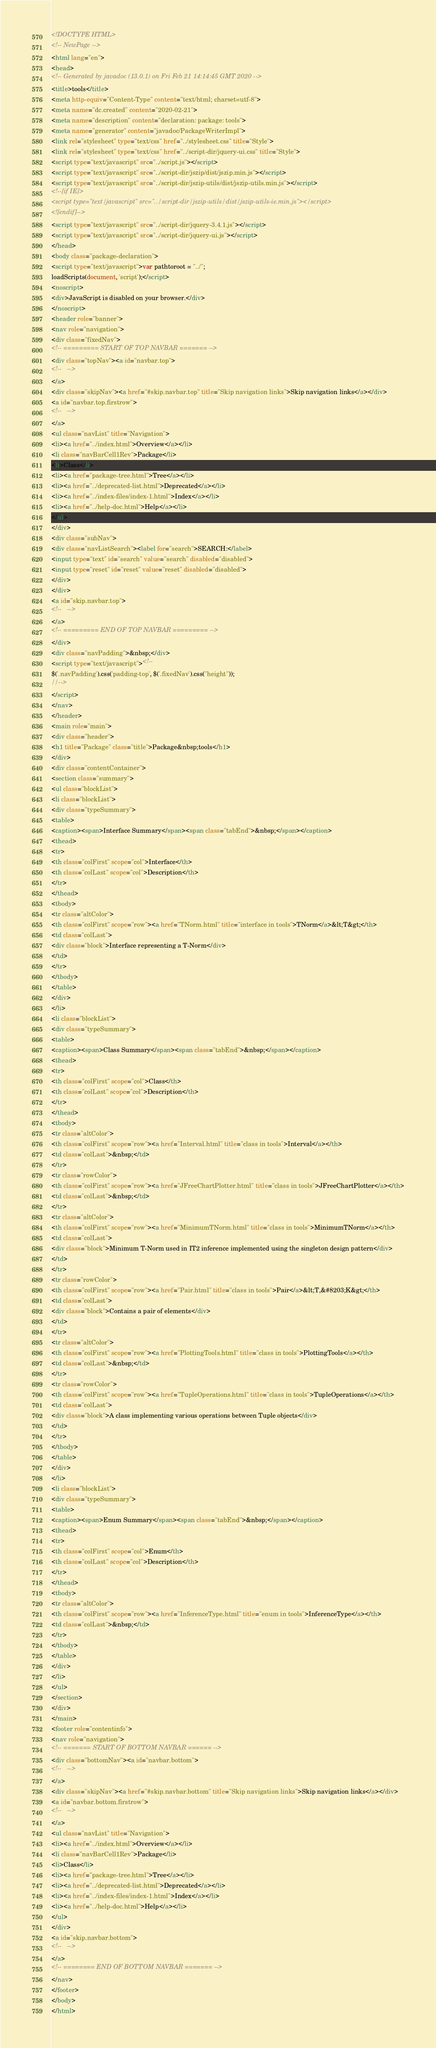<code> <loc_0><loc_0><loc_500><loc_500><_HTML_><!DOCTYPE HTML>
<!-- NewPage -->
<html lang="en">
<head>
<!-- Generated by javadoc (13.0.1) on Fri Feb 21 14:14:45 GMT 2020 -->
<title>tools</title>
<meta http-equiv="Content-Type" content="text/html; charset=utf-8">
<meta name="dc.created" content="2020-02-21">
<meta name="description" content="declaration: package: tools">
<meta name="generator" content="javadoc/PackageWriterImpl">
<link rel="stylesheet" type="text/css" href="../stylesheet.css" title="Style">
<link rel="stylesheet" type="text/css" href="../script-dir/jquery-ui.css" title="Style">
<script type="text/javascript" src="../script.js"></script>
<script type="text/javascript" src="../script-dir/jszip/dist/jszip.min.js"></script>
<script type="text/javascript" src="../script-dir/jszip-utils/dist/jszip-utils.min.js"></script>
<!--[if IE]>
<script type="text/javascript" src="../script-dir/jszip-utils/dist/jszip-utils-ie.min.js"></script>
<![endif]-->
<script type="text/javascript" src="../script-dir/jquery-3.4.1.js"></script>
<script type="text/javascript" src="../script-dir/jquery-ui.js"></script>
</head>
<body class="package-declaration">
<script type="text/javascript">var pathtoroot = "../";
loadScripts(document, 'script');</script>
<noscript>
<div>JavaScript is disabled on your browser.</div>
</noscript>
<header role="banner">
<nav role="navigation">
<div class="fixedNav">
<!-- ========= START OF TOP NAVBAR ======= -->
<div class="topNav"><a id="navbar.top">
<!--   -->
</a>
<div class="skipNav"><a href="#skip.navbar.top" title="Skip navigation links">Skip navigation links</a></div>
<a id="navbar.top.firstrow">
<!--   -->
</a>
<ul class="navList" title="Navigation">
<li><a href="../index.html">Overview</a></li>
<li class="navBarCell1Rev">Package</li>
<li>Class</li>
<li><a href="package-tree.html">Tree</a></li>
<li><a href="../deprecated-list.html">Deprecated</a></li>
<li><a href="../index-files/index-1.html">Index</a></li>
<li><a href="../help-doc.html">Help</a></li>
</ul>
</div>
<div class="subNav">
<div class="navListSearch"><label for="search">SEARCH:</label>
<input type="text" id="search" value="search" disabled="disabled">
<input type="reset" id="reset" value="reset" disabled="disabled">
</div>
</div>
<a id="skip.navbar.top">
<!--   -->
</a>
<!-- ========= END OF TOP NAVBAR ========= -->
</div>
<div class="navPadding">&nbsp;</div>
<script type="text/javascript"><!--
$('.navPadding').css('padding-top', $('.fixedNav').css("height"));
//-->
</script>
</nav>
</header>
<main role="main">
<div class="header">
<h1 title="Package" class="title">Package&nbsp;tools</h1>
</div>
<div class="contentContainer">
<section class="summary">
<ul class="blockList">
<li class="blockList">
<div class="typeSummary">
<table>
<caption><span>Interface Summary</span><span class="tabEnd">&nbsp;</span></caption>
<thead>
<tr>
<th class="colFirst" scope="col">Interface</th>
<th class="colLast" scope="col">Description</th>
</tr>
</thead>
<tbody>
<tr class="altColor">
<th class="colFirst" scope="row"><a href="TNorm.html" title="interface in tools">TNorm</a>&lt;T&gt;</th>
<td class="colLast">
<div class="block">Interface representing a T-Norm</div>
</td>
</tr>
</tbody>
</table>
</div>
</li>
<li class="blockList">
<div class="typeSummary">
<table>
<caption><span>Class Summary</span><span class="tabEnd">&nbsp;</span></caption>
<thead>
<tr>
<th class="colFirst" scope="col">Class</th>
<th class="colLast" scope="col">Description</th>
</tr>
</thead>
<tbody>
<tr class="altColor">
<th class="colFirst" scope="row"><a href="Interval.html" title="class in tools">Interval</a></th>
<td class="colLast">&nbsp;</td>
</tr>
<tr class="rowColor">
<th class="colFirst" scope="row"><a href="JFreeChartPlotter.html" title="class in tools">JFreeChartPlotter</a></th>
<td class="colLast">&nbsp;</td>
</tr>
<tr class="altColor">
<th class="colFirst" scope="row"><a href="MinimumTNorm.html" title="class in tools">MinimumTNorm</a></th>
<td class="colLast">
<div class="block">Minimum T-Norm used in IT2 inference implemented using the singleton design pattern</div>
</td>
</tr>
<tr class="rowColor">
<th class="colFirst" scope="row"><a href="Pair.html" title="class in tools">Pair</a>&lt;T,&#8203;K&gt;</th>
<td class="colLast">
<div class="block">Contains a pair of elements</div>
</td>
</tr>
<tr class="altColor">
<th class="colFirst" scope="row"><a href="PlottingTools.html" title="class in tools">PlottingTools</a></th>
<td class="colLast">&nbsp;</td>
</tr>
<tr class="rowColor">
<th class="colFirst" scope="row"><a href="TupleOperations.html" title="class in tools">TupleOperations</a></th>
<td class="colLast">
<div class="block">A class implementing various operations between Tuple objects</div>
</td>
</tr>
</tbody>
</table>
</div>
</li>
<li class="blockList">
<div class="typeSummary">
<table>
<caption><span>Enum Summary</span><span class="tabEnd">&nbsp;</span></caption>
<thead>
<tr>
<th class="colFirst" scope="col">Enum</th>
<th class="colLast" scope="col">Description</th>
</tr>
</thead>
<tbody>
<tr class="altColor">
<th class="colFirst" scope="row"><a href="InferenceType.html" title="enum in tools">InferenceType</a></th>
<td class="colLast">&nbsp;</td>
</tr>
</tbody>
</table>
</div>
</li>
</ul>
</section>
</div>
</main>
<footer role="contentinfo">
<nav role="navigation">
<!-- ======= START OF BOTTOM NAVBAR ====== -->
<div class="bottomNav"><a id="navbar.bottom">
<!--   -->
</a>
<div class="skipNav"><a href="#skip.navbar.bottom" title="Skip navigation links">Skip navigation links</a></div>
<a id="navbar.bottom.firstrow">
<!--   -->
</a>
<ul class="navList" title="Navigation">
<li><a href="../index.html">Overview</a></li>
<li class="navBarCell1Rev">Package</li>
<li>Class</li>
<li><a href="package-tree.html">Tree</a></li>
<li><a href="../deprecated-list.html">Deprecated</a></li>
<li><a href="../index-files/index-1.html">Index</a></li>
<li><a href="../help-doc.html">Help</a></li>
</ul>
</div>
<a id="skip.navbar.bottom">
<!--   -->
</a>
<!-- ======== END OF BOTTOM NAVBAR ======= -->
</nav>
</footer>
</body>
</html>
</code> 